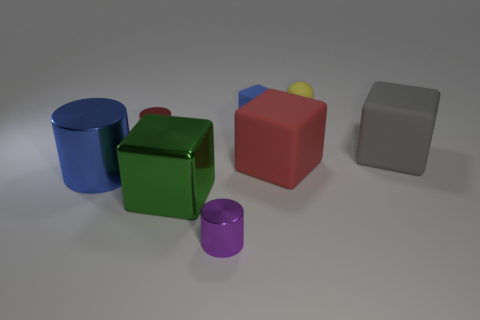What size is the blue shiny object that is on the left side of the tiny metal cylinder in front of the large cylinder?
Offer a terse response. Large. What is the material of the red object that is the same shape as the small blue object?
Your response must be concise. Rubber. How many green matte objects are there?
Provide a succinct answer. 0. There is a block in front of the matte object that is in front of the large object right of the small yellow rubber thing; what is its color?
Ensure brevity in your answer.  Green. Is the number of big blue cylinders less than the number of big matte blocks?
Make the answer very short. Yes. The other metal thing that is the same shape as the tiny blue thing is what color?
Ensure brevity in your answer.  Green. There is a tiny object that is made of the same material as the yellow sphere; what is its color?
Offer a terse response. Blue. What number of red things have the same size as the yellow thing?
Your answer should be very brief. 1. What is the material of the small sphere?
Ensure brevity in your answer.  Rubber. Is the number of large blue rubber cubes greater than the number of blue rubber cubes?
Your response must be concise. No. 